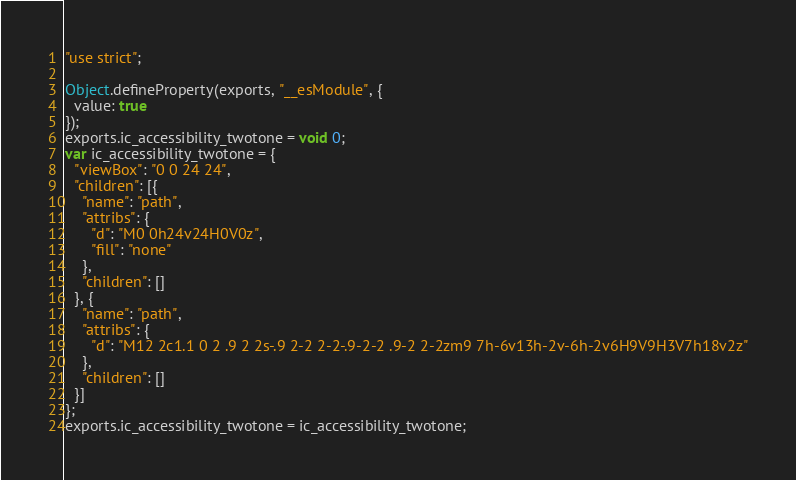Convert code to text. <code><loc_0><loc_0><loc_500><loc_500><_JavaScript_>"use strict";

Object.defineProperty(exports, "__esModule", {
  value: true
});
exports.ic_accessibility_twotone = void 0;
var ic_accessibility_twotone = {
  "viewBox": "0 0 24 24",
  "children": [{
    "name": "path",
    "attribs": {
      "d": "M0 0h24v24H0V0z",
      "fill": "none"
    },
    "children": []
  }, {
    "name": "path",
    "attribs": {
      "d": "M12 2c1.1 0 2 .9 2 2s-.9 2-2 2-2-.9-2-2 .9-2 2-2zm9 7h-6v13h-2v-6h-2v6H9V9H3V7h18v2z"
    },
    "children": []
  }]
};
exports.ic_accessibility_twotone = ic_accessibility_twotone;</code> 